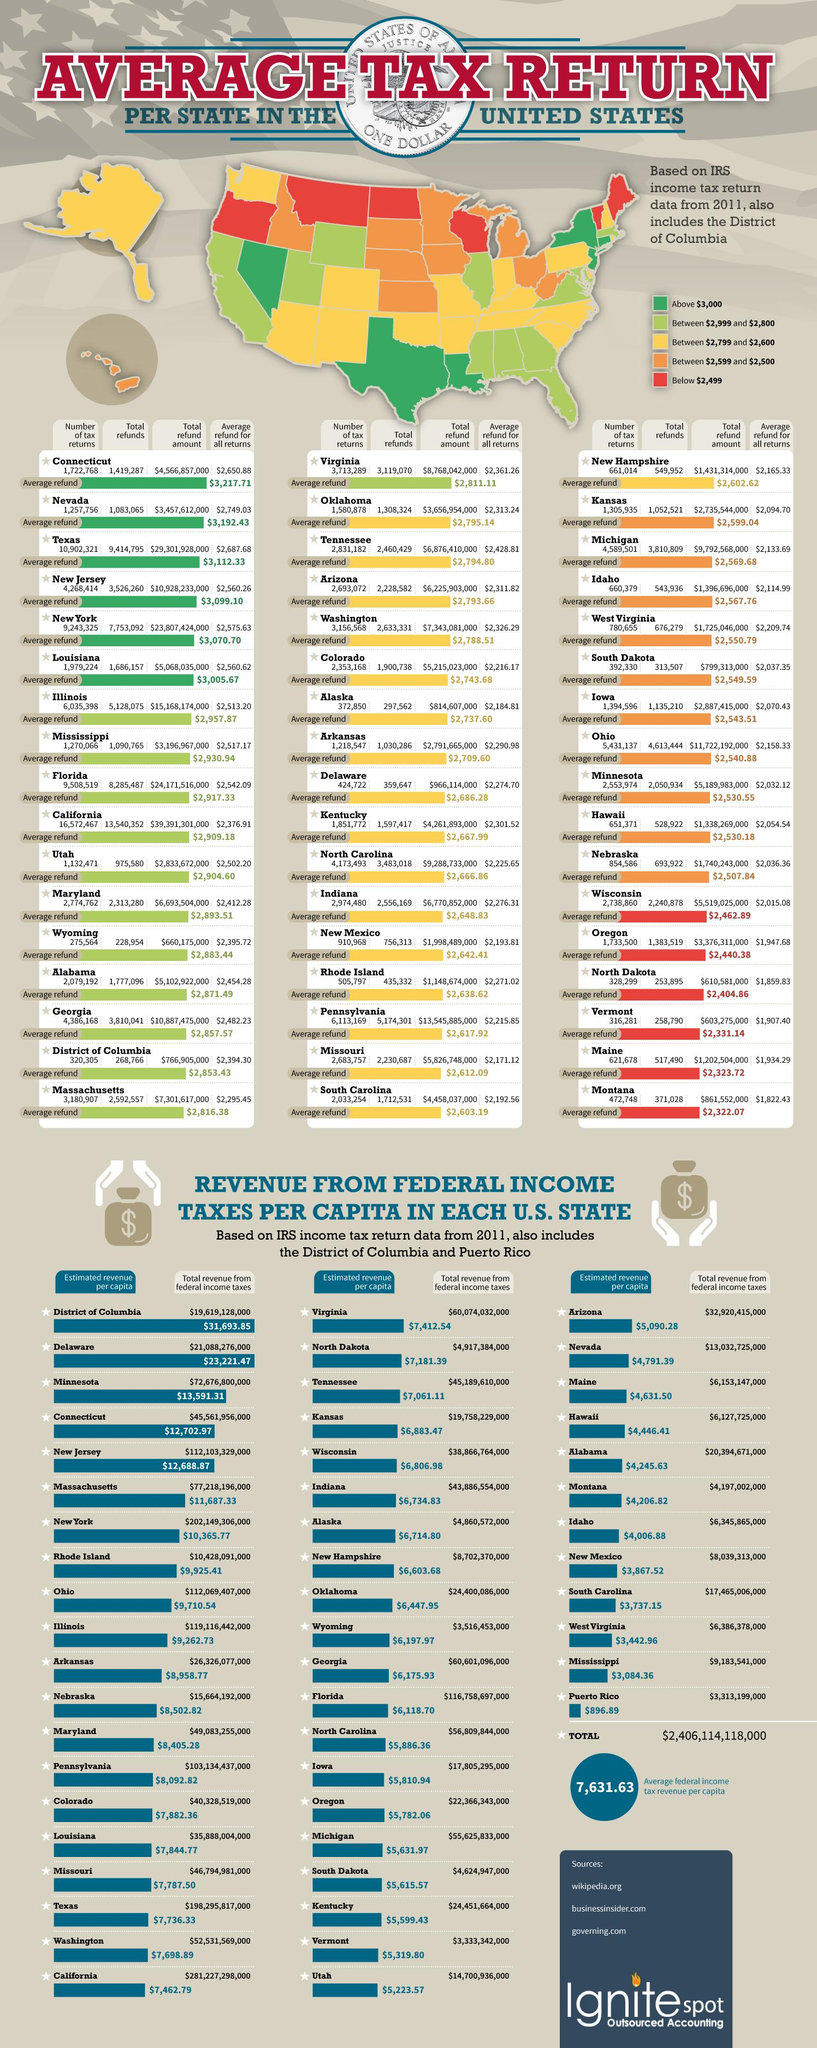Indicate a few pertinent items in this graphic. The average refund for all returns in Idaho is $2,114.99. Six states are located in the color red. The total revenue generated from federal income taxes in North Dakota for the year was $4,917,384,000. The total refund for Louisiana is 1,686,157. The average refund in Oklahoma is $2,795.14. 